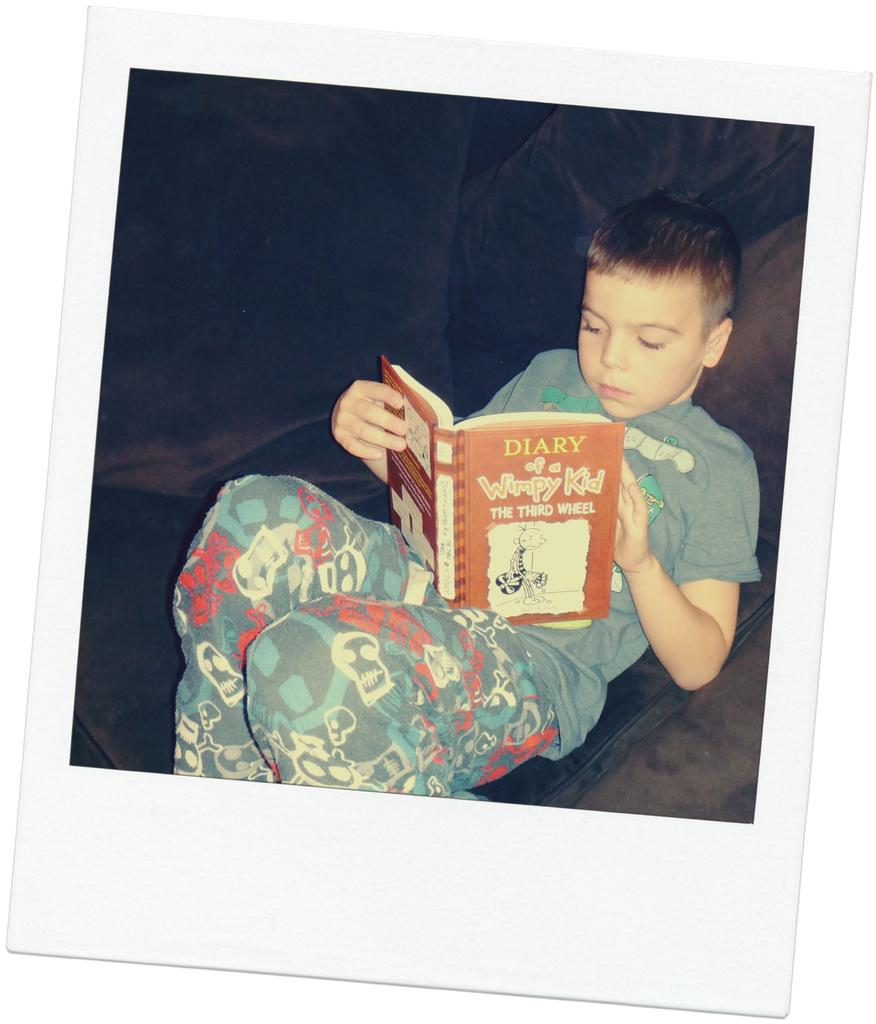<image>
Give a short and clear explanation of the subsequent image. A little boy reading a book from the Diary of a Wimpy Kid series. 